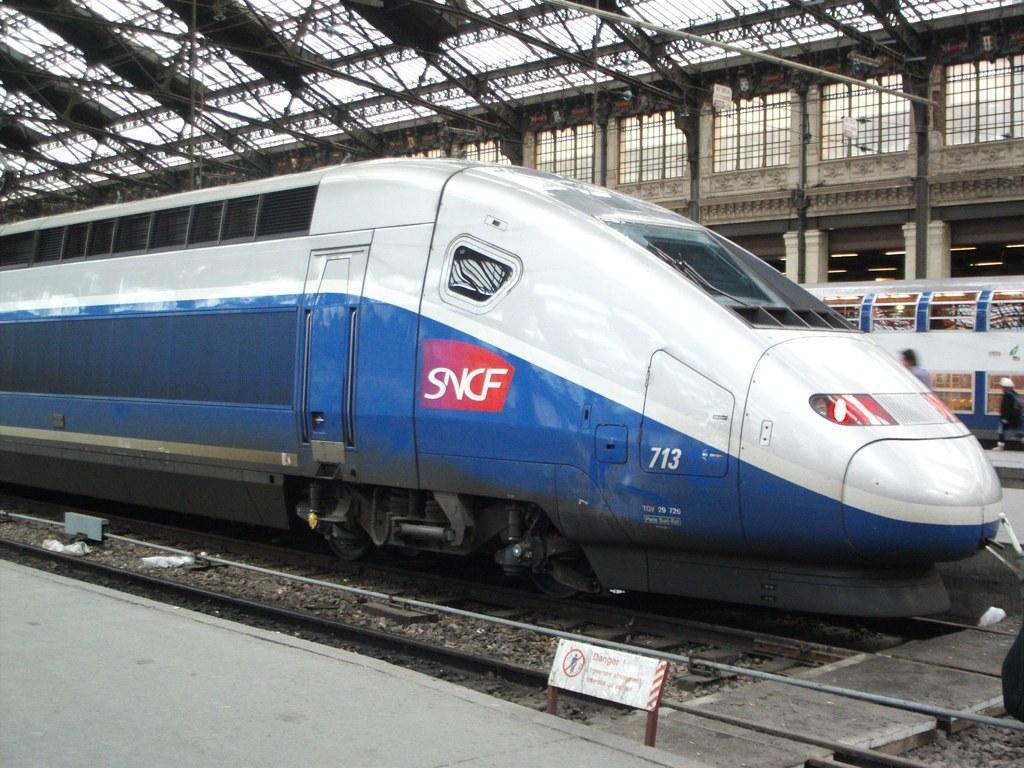In one or two sentences, can you explain what this image depicts? In this picture there is a train on the railway track, beside that we can see the platforms. On the right there is a man who is wearing black dress. He is standing near to the other train, beside him i can see another man who is standing on the platform. At the bottom there is a sign board. At the top i can see the shed. 